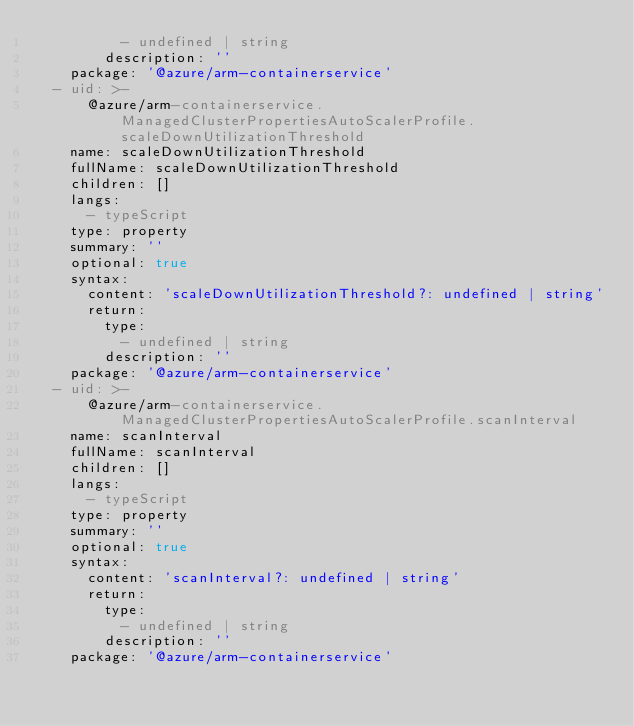Convert code to text. <code><loc_0><loc_0><loc_500><loc_500><_YAML_>          - undefined | string
        description: ''
    package: '@azure/arm-containerservice'
  - uid: >-
      @azure/arm-containerservice.ManagedClusterPropertiesAutoScalerProfile.scaleDownUtilizationThreshold
    name: scaleDownUtilizationThreshold
    fullName: scaleDownUtilizationThreshold
    children: []
    langs:
      - typeScript
    type: property
    summary: ''
    optional: true
    syntax:
      content: 'scaleDownUtilizationThreshold?: undefined | string'
      return:
        type:
          - undefined | string
        description: ''
    package: '@azure/arm-containerservice'
  - uid: >-
      @azure/arm-containerservice.ManagedClusterPropertiesAutoScalerProfile.scanInterval
    name: scanInterval
    fullName: scanInterval
    children: []
    langs:
      - typeScript
    type: property
    summary: ''
    optional: true
    syntax:
      content: 'scanInterval?: undefined | string'
      return:
        type:
          - undefined | string
        description: ''
    package: '@azure/arm-containerservice'
</code> 